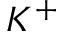<formula> <loc_0><loc_0><loc_500><loc_500>K ^ { + }</formula> 